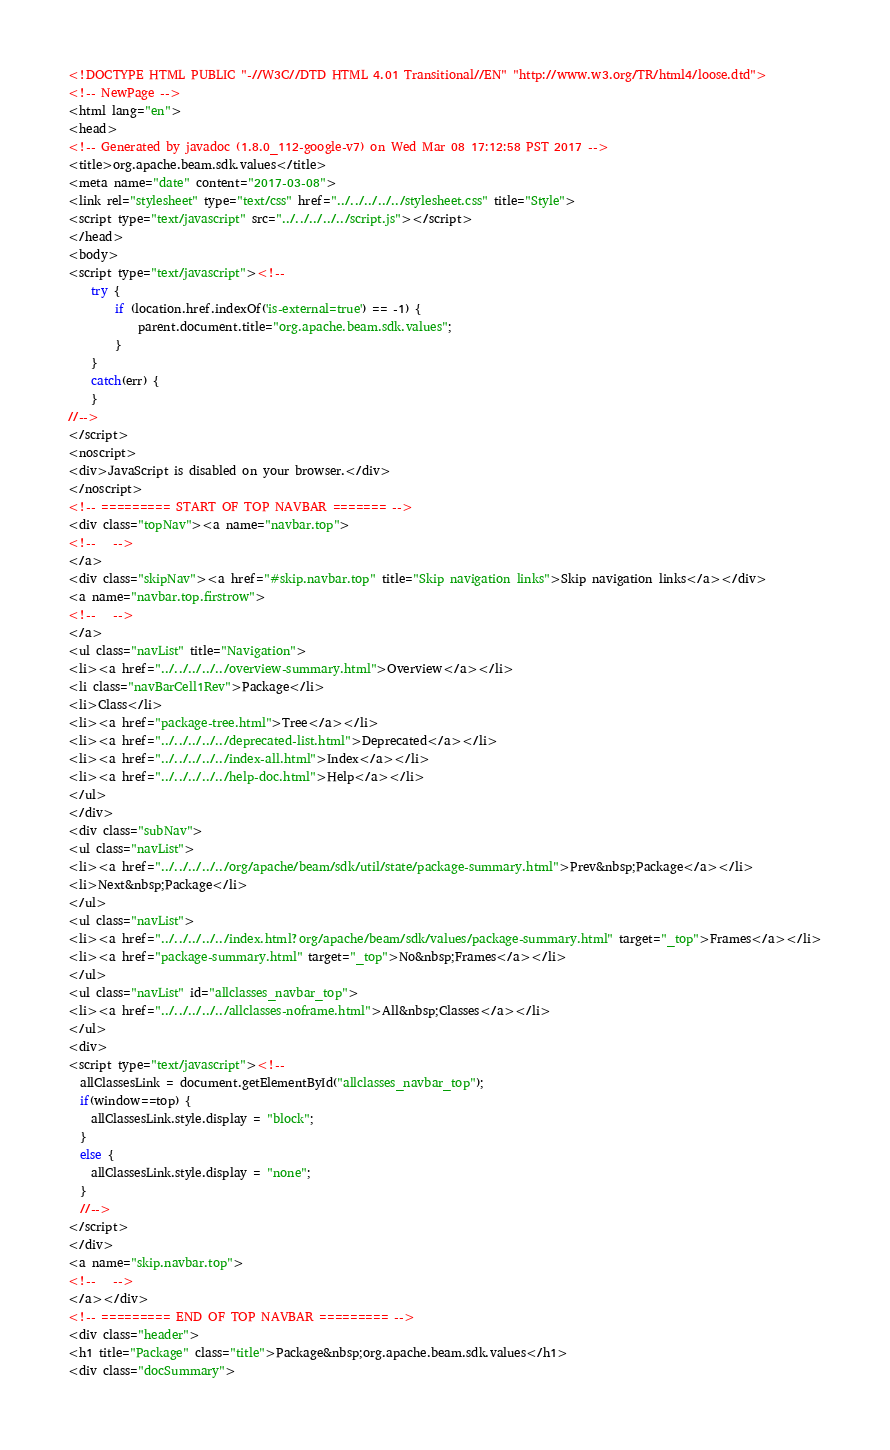<code> <loc_0><loc_0><loc_500><loc_500><_HTML_><!DOCTYPE HTML PUBLIC "-//W3C//DTD HTML 4.01 Transitional//EN" "http://www.w3.org/TR/html4/loose.dtd">
<!-- NewPage -->
<html lang="en">
<head>
<!-- Generated by javadoc (1.8.0_112-google-v7) on Wed Mar 08 17:12:58 PST 2017 -->
<title>org.apache.beam.sdk.values</title>
<meta name="date" content="2017-03-08">
<link rel="stylesheet" type="text/css" href="../../../../../stylesheet.css" title="Style">
<script type="text/javascript" src="../../../../../script.js"></script>
</head>
<body>
<script type="text/javascript"><!--
    try {
        if (location.href.indexOf('is-external=true') == -1) {
            parent.document.title="org.apache.beam.sdk.values";
        }
    }
    catch(err) {
    }
//-->
</script>
<noscript>
<div>JavaScript is disabled on your browser.</div>
</noscript>
<!-- ========= START OF TOP NAVBAR ======= -->
<div class="topNav"><a name="navbar.top">
<!--   -->
</a>
<div class="skipNav"><a href="#skip.navbar.top" title="Skip navigation links">Skip navigation links</a></div>
<a name="navbar.top.firstrow">
<!--   -->
</a>
<ul class="navList" title="Navigation">
<li><a href="../../../../../overview-summary.html">Overview</a></li>
<li class="navBarCell1Rev">Package</li>
<li>Class</li>
<li><a href="package-tree.html">Tree</a></li>
<li><a href="../../../../../deprecated-list.html">Deprecated</a></li>
<li><a href="../../../../../index-all.html">Index</a></li>
<li><a href="../../../../../help-doc.html">Help</a></li>
</ul>
</div>
<div class="subNav">
<ul class="navList">
<li><a href="../../../../../org/apache/beam/sdk/util/state/package-summary.html">Prev&nbsp;Package</a></li>
<li>Next&nbsp;Package</li>
</ul>
<ul class="navList">
<li><a href="../../../../../index.html?org/apache/beam/sdk/values/package-summary.html" target="_top">Frames</a></li>
<li><a href="package-summary.html" target="_top">No&nbsp;Frames</a></li>
</ul>
<ul class="navList" id="allclasses_navbar_top">
<li><a href="../../../../../allclasses-noframe.html">All&nbsp;Classes</a></li>
</ul>
<div>
<script type="text/javascript"><!--
  allClassesLink = document.getElementById("allclasses_navbar_top");
  if(window==top) {
    allClassesLink.style.display = "block";
  }
  else {
    allClassesLink.style.display = "none";
  }
  //-->
</script>
</div>
<a name="skip.navbar.top">
<!--   -->
</a></div>
<!-- ========= END OF TOP NAVBAR ========= -->
<div class="header">
<h1 title="Package" class="title">Package&nbsp;org.apache.beam.sdk.values</h1>
<div class="docSummary"></code> 